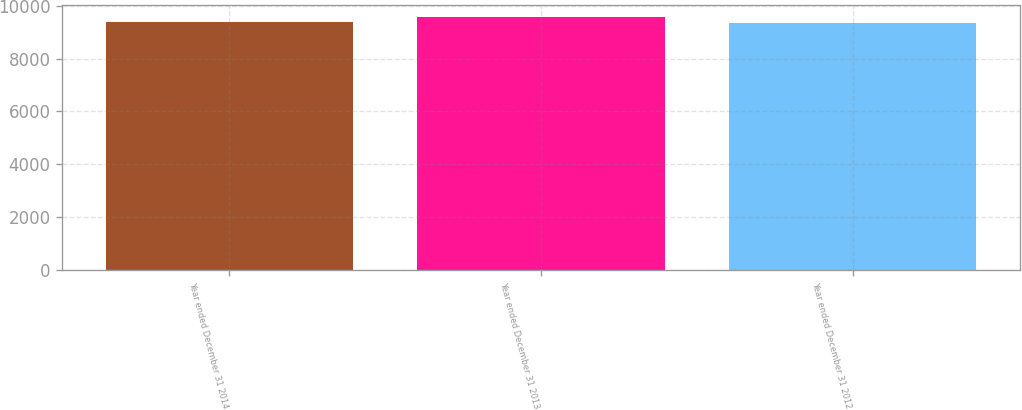Convert chart to OTSL. <chart><loc_0><loc_0><loc_500><loc_500><bar_chart><fcel>Year ended December 31 2014<fcel>Year ended December 31 2013<fcel>Year ended December 31 2012<nl><fcel>9391.9<fcel>9571<fcel>9372<nl></chart> 